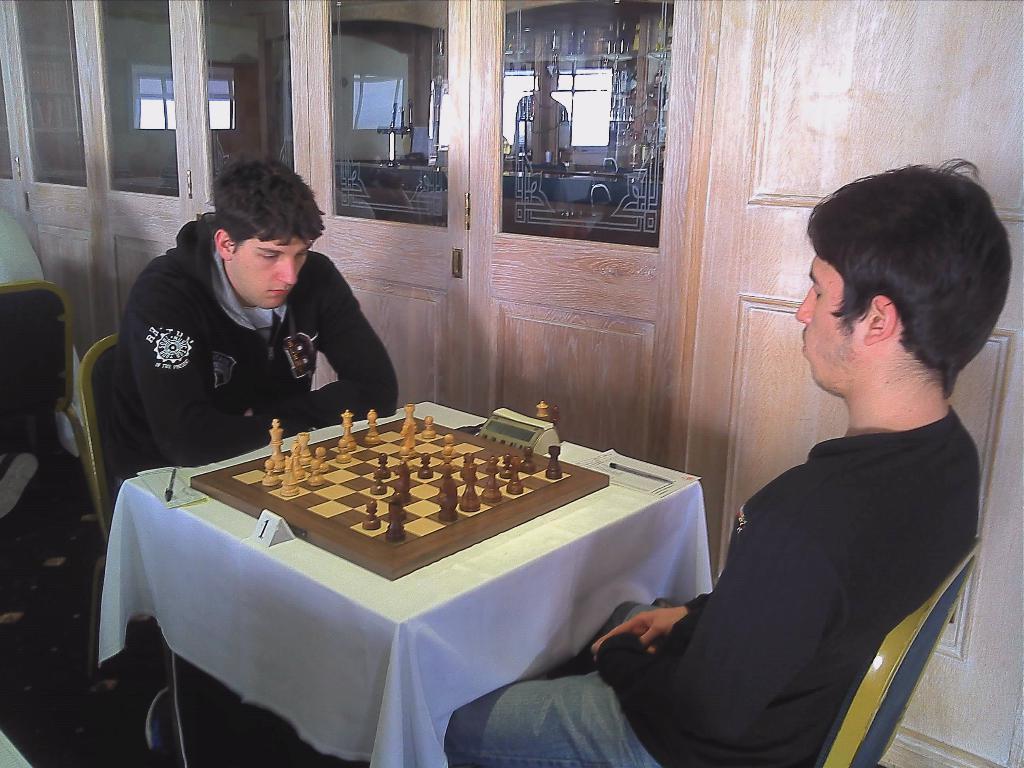In one or two sentences, can you explain what this image depicts? Two men are sitting on the chairs and playing the chess both of them are wearing black color coats. 